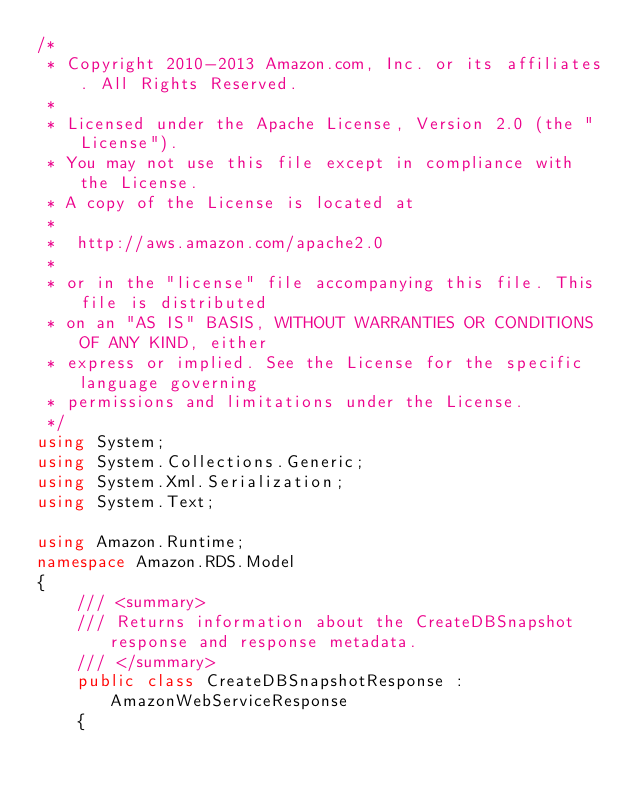Convert code to text. <code><loc_0><loc_0><loc_500><loc_500><_C#_>/*
 * Copyright 2010-2013 Amazon.com, Inc. or its affiliates. All Rights Reserved.
 * 
 * Licensed under the Apache License, Version 2.0 (the "License").
 * You may not use this file except in compliance with the License.
 * A copy of the License is located at
 * 
 *  http://aws.amazon.com/apache2.0
 * 
 * or in the "license" file accompanying this file. This file is distributed
 * on an "AS IS" BASIS, WITHOUT WARRANTIES OR CONDITIONS OF ANY KIND, either
 * express or implied. See the License for the specific language governing
 * permissions and limitations under the License.
 */
using System;
using System.Collections.Generic;
using System.Xml.Serialization;
using System.Text;

using Amazon.Runtime;
namespace Amazon.RDS.Model
{
    /// <summary>
    /// Returns information about the CreateDBSnapshot response and response metadata.
    /// </summary>
    public class CreateDBSnapshotResponse : AmazonWebServiceResponse
    {</code> 